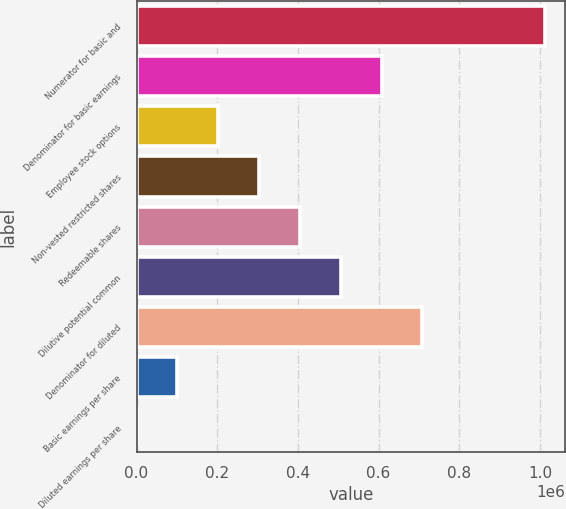<chart> <loc_0><loc_0><loc_500><loc_500><bar_chart><fcel>Numerator for basic and<fcel>Denominator for basic earnings<fcel>Employee stock options<fcel>Non-vested restricted shares<fcel>Redeemable shares<fcel>Dilutive potential common<fcel>Denominator for diluted<fcel>Basic earnings per share<fcel>Diluted earnings per share<nl><fcel>1.0124e+06<fcel>607439<fcel>202482<fcel>303721<fcel>404960<fcel>506200<fcel>708679<fcel>101242<fcel>2.81<nl></chart> 